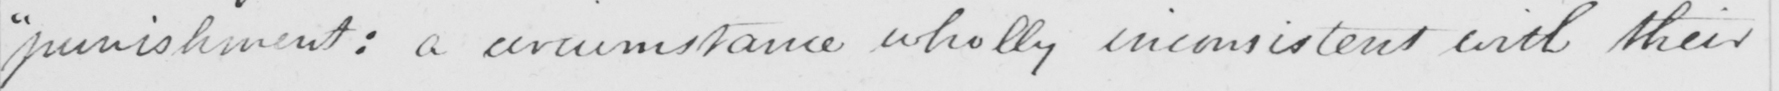Can you tell me what this handwritten text says? punishment :  a circumstance wholly inconsistent with their 